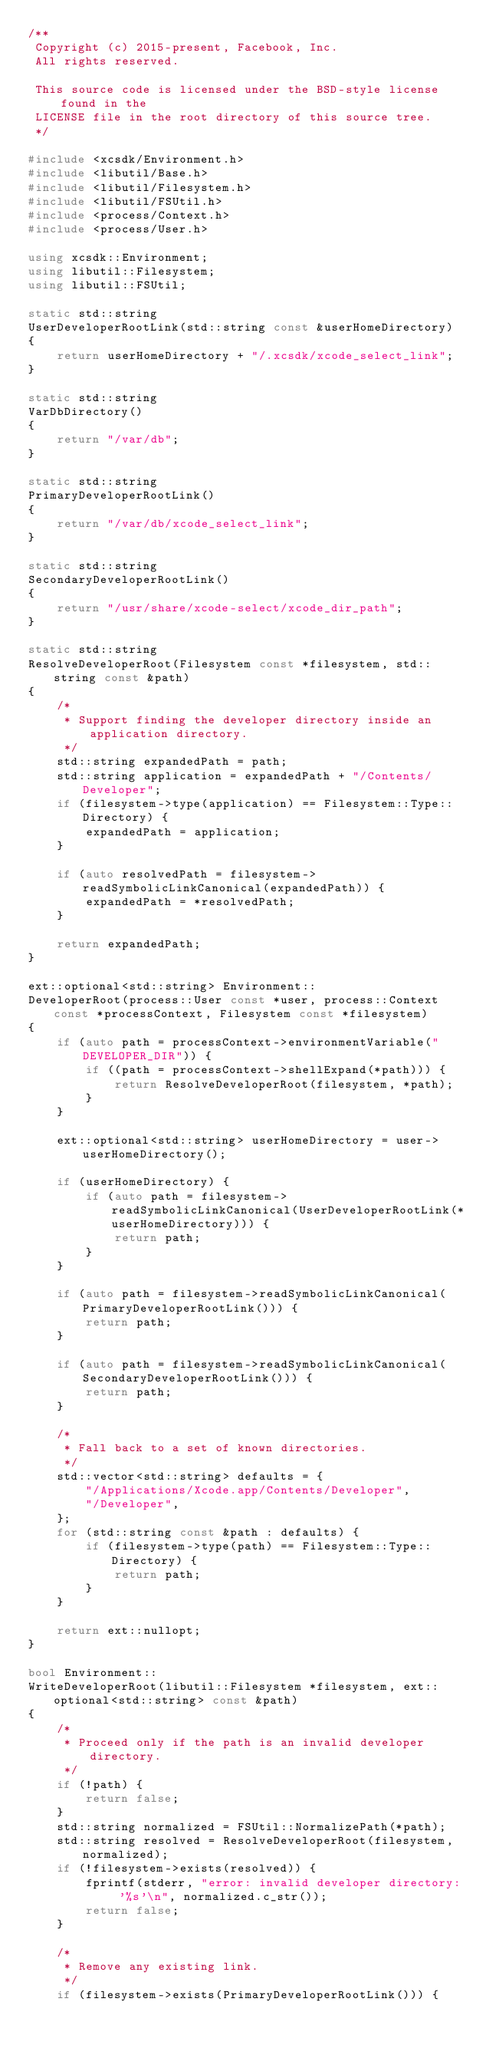Convert code to text. <code><loc_0><loc_0><loc_500><loc_500><_C++_>/**
 Copyright (c) 2015-present, Facebook, Inc.
 All rights reserved.

 This source code is licensed under the BSD-style license found in the
 LICENSE file in the root directory of this source tree.
 */

#include <xcsdk/Environment.h>
#include <libutil/Base.h>
#include <libutil/Filesystem.h>
#include <libutil/FSUtil.h>
#include <process/Context.h>
#include <process/User.h>

using xcsdk::Environment;
using libutil::Filesystem;
using libutil::FSUtil;

static std::string
UserDeveloperRootLink(std::string const &userHomeDirectory)
{
    return userHomeDirectory + "/.xcsdk/xcode_select_link";
}

static std::string
VarDbDirectory()
{
    return "/var/db";
}

static std::string
PrimaryDeveloperRootLink()
{
    return "/var/db/xcode_select_link";
}

static std::string
SecondaryDeveloperRootLink()
{
    return "/usr/share/xcode-select/xcode_dir_path";
}

static std::string
ResolveDeveloperRoot(Filesystem const *filesystem, std::string const &path)
{
    /*
     * Support finding the developer directory inside an application directory.
     */
    std::string expandedPath = path;
    std::string application = expandedPath + "/Contents/Developer";
    if (filesystem->type(application) == Filesystem::Type::Directory) {
        expandedPath = application;
    }

    if (auto resolvedPath = filesystem->readSymbolicLinkCanonical(expandedPath)) {
        expandedPath = *resolvedPath;
    }

    return expandedPath;
}

ext::optional<std::string> Environment::
DeveloperRoot(process::User const *user, process::Context const *processContext, Filesystem const *filesystem)
{
    if (auto path = processContext->environmentVariable("DEVELOPER_DIR")) {
        if ((path = processContext->shellExpand(*path))) {
            return ResolveDeveloperRoot(filesystem, *path);
        }
    }

    ext::optional<std::string> userHomeDirectory = user->userHomeDirectory();

    if (userHomeDirectory) {
        if (auto path = filesystem->readSymbolicLinkCanonical(UserDeveloperRootLink(*userHomeDirectory))) {
            return path;
        }
    }

    if (auto path = filesystem->readSymbolicLinkCanonical(PrimaryDeveloperRootLink())) {
        return path;
    }

    if (auto path = filesystem->readSymbolicLinkCanonical(SecondaryDeveloperRootLink())) {
        return path;
    }

    /*
     * Fall back to a set of known directories.
     */
    std::vector<std::string> defaults = {
        "/Applications/Xcode.app/Contents/Developer",
        "/Developer",
    };
    for (std::string const &path : defaults) {
        if (filesystem->type(path) == Filesystem::Type::Directory) {
            return path;
        }
    }

    return ext::nullopt;
}

bool Environment::
WriteDeveloperRoot(libutil::Filesystem *filesystem, ext::optional<std::string> const &path)
{
    /*
     * Proceed only if the path is an invalid developer directory.
     */
    if (!path) {
        return false;
    }
    std::string normalized = FSUtil::NormalizePath(*path);
    std::string resolved = ResolveDeveloperRoot(filesystem, normalized);
    if (!filesystem->exists(resolved)) {
        fprintf(stderr, "error: invalid developer directory: '%s'\n", normalized.c_str());
        return false;
    }

    /*
     * Remove any existing link.
     */
    if (filesystem->exists(PrimaryDeveloperRootLink())) {</code> 